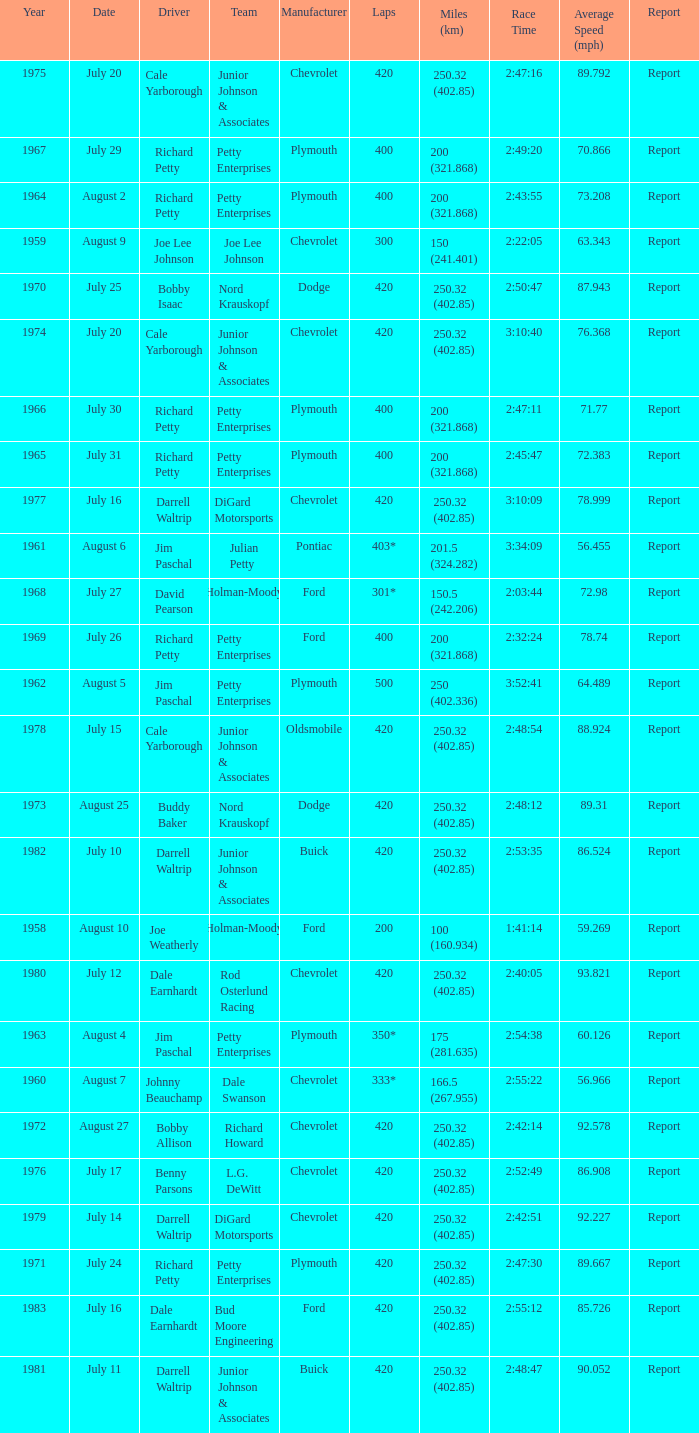Could you help me parse every detail presented in this table? {'header': ['Year', 'Date', 'Driver', 'Team', 'Manufacturer', 'Laps', 'Miles (km)', 'Race Time', 'Average Speed (mph)', 'Report'], 'rows': [['1975', 'July 20', 'Cale Yarborough', 'Junior Johnson & Associates', 'Chevrolet', '420', '250.32 (402.85)', '2:47:16', '89.792', 'Report'], ['1967', 'July 29', 'Richard Petty', 'Petty Enterprises', 'Plymouth', '400', '200 (321.868)', '2:49:20', '70.866', 'Report'], ['1964', 'August 2', 'Richard Petty', 'Petty Enterprises', 'Plymouth', '400', '200 (321.868)', '2:43:55', '73.208', 'Report'], ['1959', 'August 9', 'Joe Lee Johnson', 'Joe Lee Johnson', 'Chevrolet', '300', '150 (241.401)', '2:22:05', '63.343', 'Report'], ['1970', 'July 25', 'Bobby Isaac', 'Nord Krauskopf', 'Dodge', '420', '250.32 (402.85)', '2:50:47', '87.943', 'Report'], ['1974', 'July 20', 'Cale Yarborough', 'Junior Johnson & Associates', 'Chevrolet', '420', '250.32 (402.85)', '3:10:40', '76.368', 'Report'], ['1966', 'July 30', 'Richard Petty', 'Petty Enterprises', 'Plymouth', '400', '200 (321.868)', '2:47:11', '71.77', 'Report'], ['1965', 'July 31', 'Richard Petty', 'Petty Enterprises', 'Plymouth', '400', '200 (321.868)', '2:45:47', '72.383', 'Report'], ['1977', 'July 16', 'Darrell Waltrip', 'DiGard Motorsports', 'Chevrolet', '420', '250.32 (402.85)', '3:10:09', '78.999', 'Report'], ['1961', 'August 6', 'Jim Paschal', 'Julian Petty', 'Pontiac', '403*', '201.5 (324.282)', '3:34:09', '56.455', 'Report'], ['1968', 'July 27', 'David Pearson', 'Holman-Moody', 'Ford', '301*', '150.5 (242.206)', '2:03:44', '72.98', 'Report'], ['1969', 'July 26', 'Richard Petty', 'Petty Enterprises', 'Ford', '400', '200 (321.868)', '2:32:24', '78.74', 'Report'], ['1962', 'August 5', 'Jim Paschal', 'Petty Enterprises', 'Plymouth', '500', '250 (402.336)', '3:52:41', '64.489', 'Report'], ['1978', 'July 15', 'Cale Yarborough', 'Junior Johnson & Associates', 'Oldsmobile', '420', '250.32 (402.85)', '2:48:54', '88.924', 'Report'], ['1973', 'August 25', 'Buddy Baker', 'Nord Krauskopf', 'Dodge', '420', '250.32 (402.85)', '2:48:12', '89.31', 'Report'], ['1982', 'July 10', 'Darrell Waltrip', 'Junior Johnson & Associates', 'Buick', '420', '250.32 (402.85)', '2:53:35', '86.524', 'Report'], ['1958', 'August 10', 'Joe Weatherly', 'Holman-Moody', 'Ford', '200', '100 (160.934)', '1:41:14', '59.269', 'Report'], ['1980', 'July 12', 'Dale Earnhardt', 'Rod Osterlund Racing', 'Chevrolet', '420', '250.32 (402.85)', '2:40:05', '93.821', 'Report'], ['1963', 'August 4', 'Jim Paschal', 'Petty Enterprises', 'Plymouth', '350*', '175 (281.635)', '2:54:38', '60.126', 'Report'], ['1960', 'August 7', 'Johnny Beauchamp', 'Dale Swanson', 'Chevrolet', '333*', '166.5 (267.955)', '2:55:22', '56.966', 'Report'], ['1972', 'August 27', 'Bobby Allison', 'Richard Howard', 'Chevrolet', '420', '250.32 (402.85)', '2:42:14', '92.578', 'Report'], ['1976', 'July 17', 'Benny Parsons', 'L.G. DeWitt', 'Chevrolet', '420', '250.32 (402.85)', '2:52:49', '86.908', 'Report'], ['1979', 'July 14', 'Darrell Waltrip', 'DiGard Motorsports', 'Chevrolet', '420', '250.32 (402.85)', '2:42:51', '92.227', 'Report'], ['1971', 'July 24', 'Richard Petty', 'Petty Enterprises', 'Plymouth', '420', '250.32 (402.85)', '2:47:30', '89.667', 'Report'], ['1983', 'July 16', 'Dale Earnhardt', 'Bud Moore Engineering', 'Ford', '420', '250.32 (402.85)', '2:55:12', '85.726', 'Report'], ['1981', 'July 11', 'Darrell Waltrip', 'Junior Johnson & Associates', 'Buick', '420', '250.32 (402.85)', '2:48:47', '90.052', 'Report']]} What date was the race in 1968 run on? July 27. 